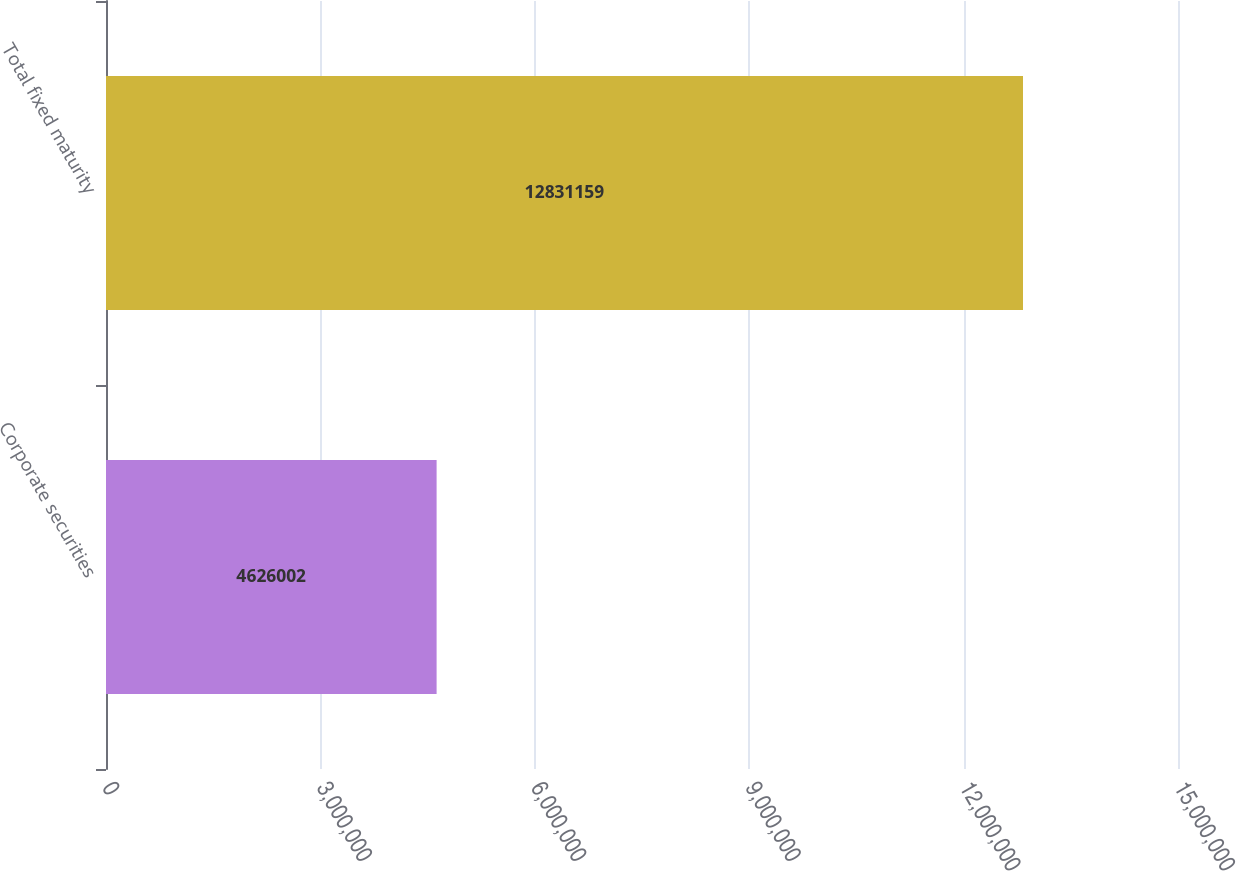Convert chart to OTSL. <chart><loc_0><loc_0><loc_500><loc_500><bar_chart><fcel>Corporate securities<fcel>Total fixed maturity<nl><fcel>4.626e+06<fcel>1.28312e+07<nl></chart> 